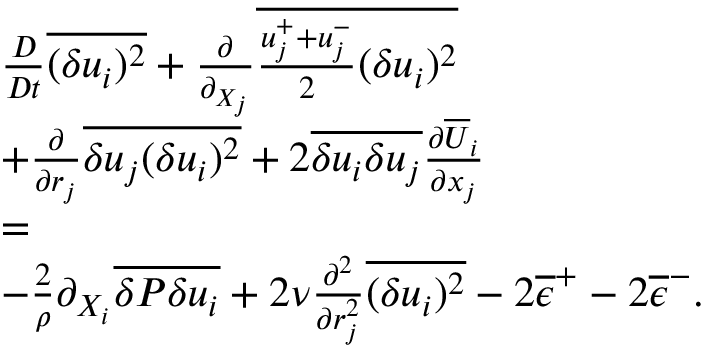<formula> <loc_0><loc_0><loc_500><loc_500>\begin{array} { r l r } & { \frac { D } { D t } \overline { { ( \delta u _ { i } ) ^ { 2 } } } + \frac { \partial } { \partial _ { X _ { j } } } \overline { { \frac { u _ { j } ^ { + } + u _ { j } ^ { - } } { 2 } ( \delta u _ { i } ) ^ { 2 } } } } & \\ & { + \frac { \partial } { \partial { r _ { j } } } \overline { { \delta u _ { j } ( \delta u _ { i } ) ^ { 2 } } } + 2 \overline { { \delta u _ { i } \delta u _ { j } } } \frac { \partial \overline { U } _ { i } } { \partial x _ { j } } } & \\ & { = } & \\ & { - \frac { 2 } { \rho } \partial _ { X _ { i } } \overline { { \delta P \delta u _ { i } } } + 2 \nu \frac { \partial ^ { 2 } } { \partial r _ { j } ^ { 2 } } \overline { { ( \delta u _ { i } ) ^ { 2 } } } - 2 \overline { \epsilon } ^ { + } - 2 \overline { \epsilon } ^ { - } . } & \end{array}</formula> 